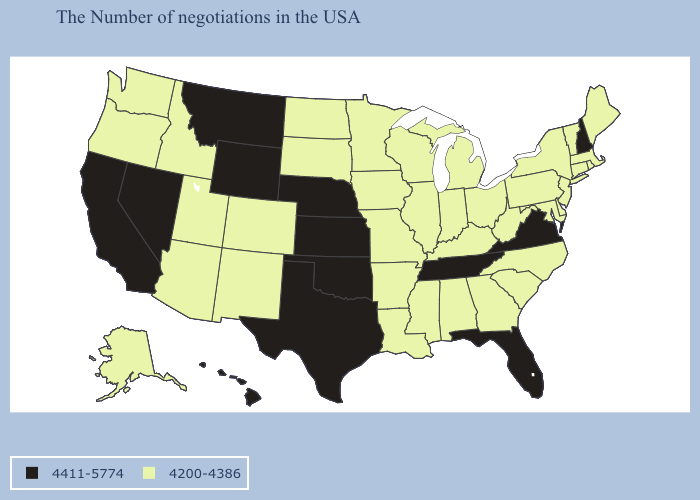Name the states that have a value in the range 4411-5774?
Quick response, please. New Hampshire, Virginia, Florida, Tennessee, Kansas, Nebraska, Oklahoma, Texas, Wyoming, Montana, Nevada, California, Hawaii. Which states have the highest value in the USA?
Quick response, please. New Hampshire, Virginia, Florida, Tennessee, Kansas, Nebraska, Oklahoma, Texas, Wyoming, Montana, Nevada, California, Hawaii. How many symbols are there in the legend?
Concise answer only. 2. What is the value of California?
Quick response, please. 4411-5774. Which states have the lowest value in the Northeast?
Concise answer only. Maine, Massachusetts, Rhode Island, Vermont, Connecticut, New York, New Jersey, Pennsylvania. Among the states that border Maryland , which have the highest value?
Write a very short answer. Virginia. Is the legend a continuous bar?
Short answer required. No. What is the highest value in the Northeast ?
Quick response, please. 4411-5774. Among the states that border Iowa , which have the highest value?
Be succinct. Nebraska. What is the lowest value in the USA?
Give a very brief answer. 4200-4386. How many symbols are there in the legend?
Quick response, please. 2. What is the value of Washington?
Answer briefly. 4200-4386. Does the map have missing data?
Keep it brief. No. What is the value of North Dakota?
Short answer required. 4200-4386. 